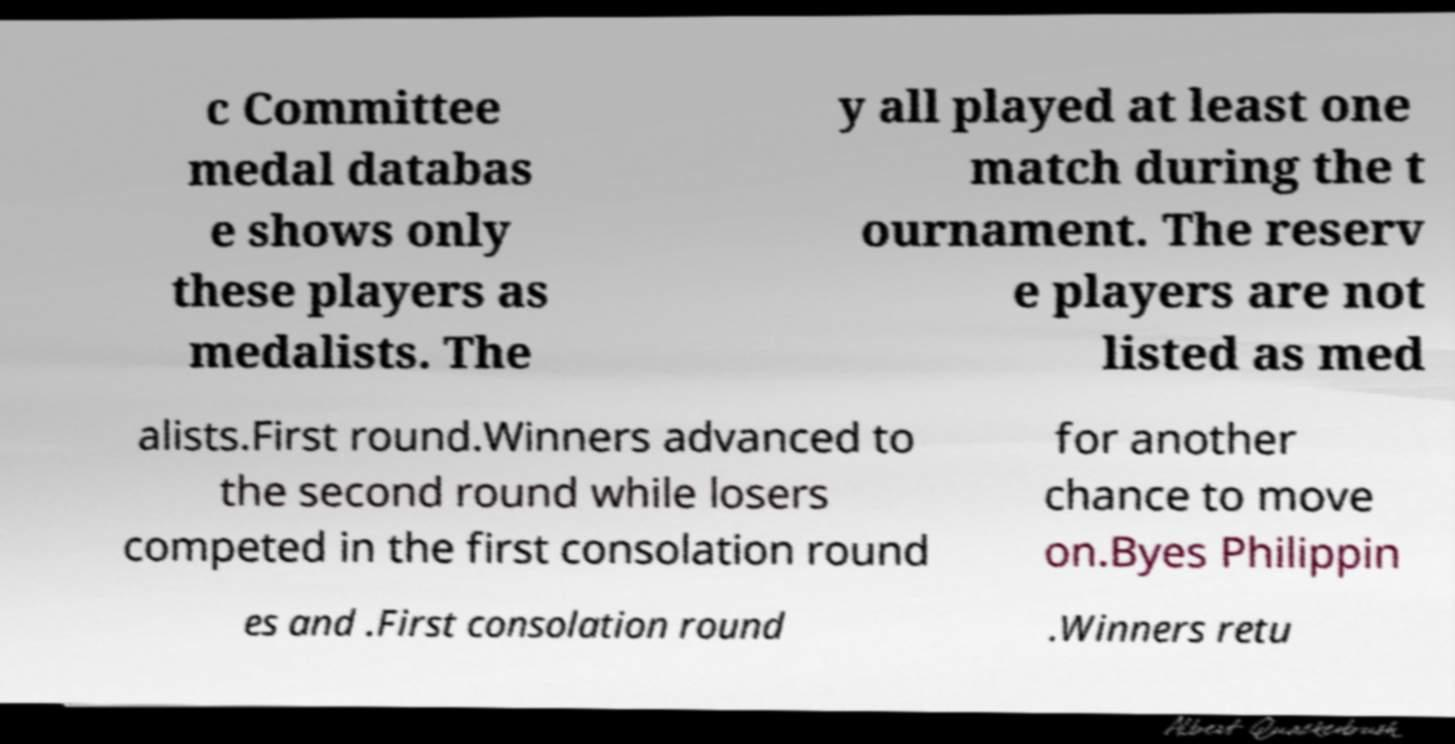Could you extract and type out the text from this image? c Committee medal databas e shows only these players as medalists. The y all played at least one match during the t ournament. The reserv e players are not listed as med alists.First round.Winners advanced to the second round while losers competed in the first consolation round for another chance to move on.Byes Philippin es and .First consolation round .Winners retu 